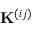Convert formula to latex. <formula><loc_0><loc_0><loc_500><loc_500>K ^ { ( i j ) }</formula> 